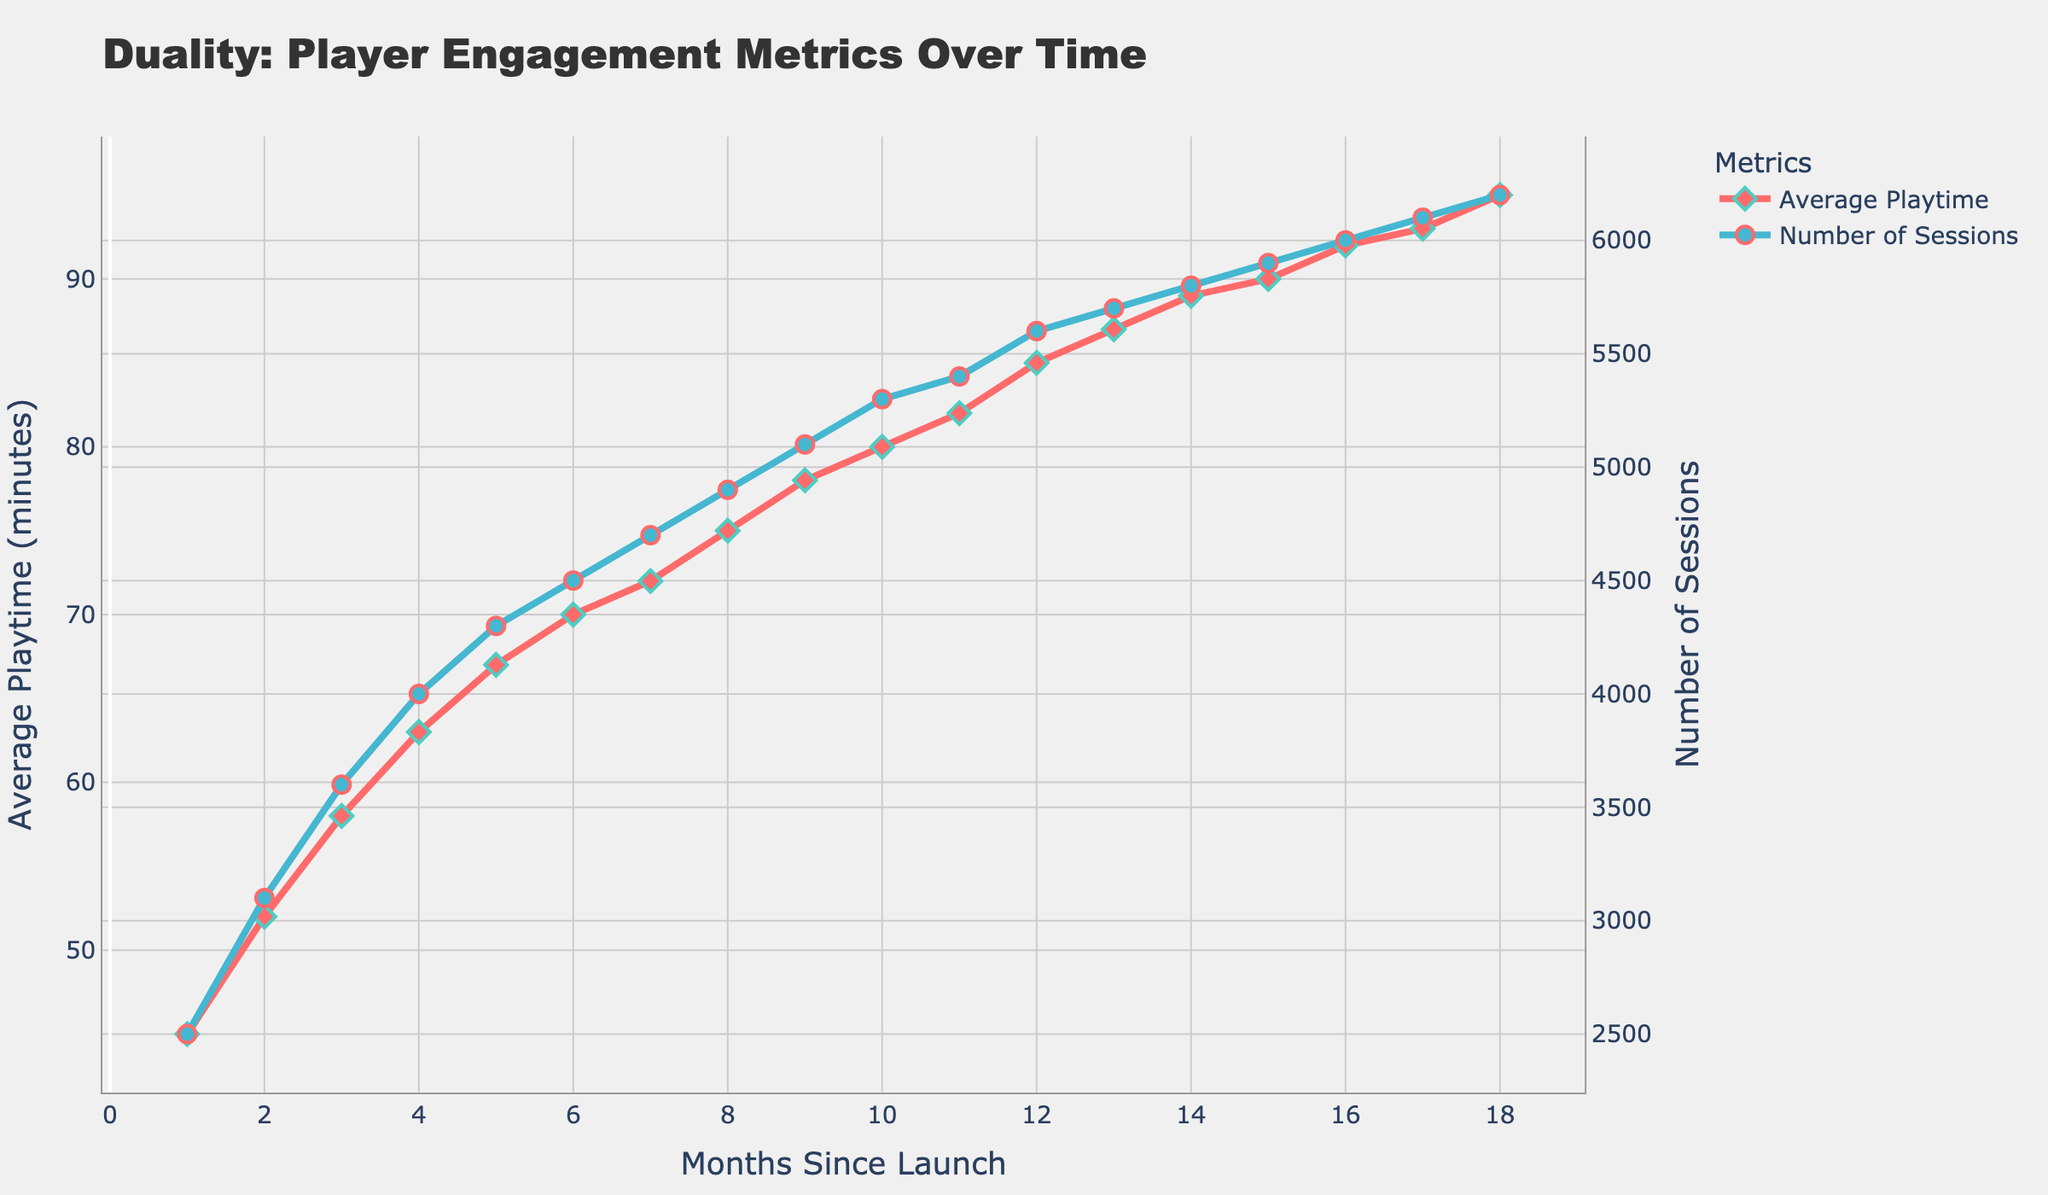What's the highest average playtime observed in the given months? To find the highest value for average playtime, we observe the line representing average playtime in the plot and look for the peak point. This peak corresponds to the highest value.
Answer: 95 minutes In which month did the number of sessions increase the most compared to the previous month? The month-over-month increase is determined by finding the difference between the number of sessions in consecutive months. To get the steepest increase, we observe where the blue line in the plot has the steepest upward slope.
Answer: Month 2 to Month 3 Which metric shows a steeper increase over time, average playtime or number of sessions? To compare the steepness of the increase, assess the slopes of both the red and blue lines. The line that trends upwards more sharply represents the steeper increase.
Answer: Number of Sessions During which month does the average playtime first exceed 80 minutes? By following the red line on the graph, we find the point where the value first surpasses 80 minutes. Then, correlate this point with the corresponding month on the x-axis.
Answer: Month 10 Between Months 4 and 8, what is the overall increase in the number of sessions? To determine the total increase, identify the number of sessions in Month 8 and subtract the value from Month 4.
Answer: 4900 - 4000 = 900 By how many sessions did the number of sessions increase from Month 1 to Month 12? To find this, subtract the number of sessions in the first month from those in the twelfth month.
Answer: 5600 - 2500 = 3100 What is the difference in average playtime between the starting month and the final month? Subtract the average playtime in Month 1 from that in Month 18.
Answer: 95 - 45 = 50 minutes In which month did the average playtime growth start to slow down significantly compared to the previous months, according to the visual trend? Observe the red line for months with a noticeable change in the steepness of the line, indicating a slowdown in growth rate.
Answer: Month 16 Which month shows the highest number of sessions in the graph? Identify the peak of the blue line on the plot, which represents the highest number of sessions.
Answer: Month 18 